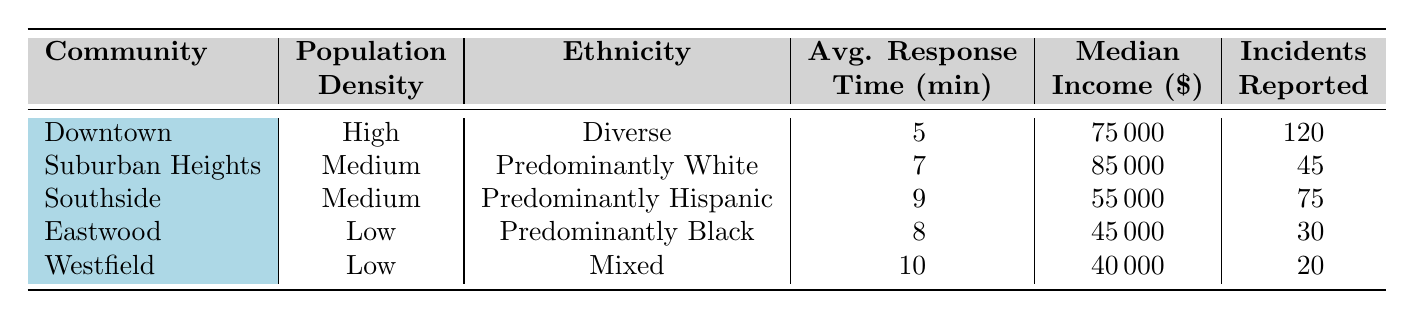What is the average response time for the Downtown community? The average response time for the Downtown community, as indicated in the table, is 5 minutes.
Answer: 5 What is the median income for Southside? The table shows that the median income for Southside is 55,000 dollars.
Answer: 55000 Which community has the highest number of incidents reported? By comparing the "Incidents Reported" column, Downtown has the highest at 120 incidents.
Answer: Downtown Is the average response time for Eastwood less than 9 minutes? The average response time for Eastwood is 8 minutes, which is indeed less than 9 minutes.
Answer: Yes What is the difference in average response time between Westfield and Suburban Heights? Westfield has an average response time of 10 minutes, and Suburban Heights has 7 minutes. The difference is 10 - 7 = 3 minutes.
Answer: 3 Which community has a predominantly Hispanic ethnicity and what is its average response time? Southside has a predominantly Hispanic ethnicity and an average response time of 9 minutes.
Answer: Southside, 9 What is the total number of incidents reported across all communities? Adding up the incidents reported: 120 (Downtown) + 45 (Suburban Heights) + 75 (Southside) + 30 (Eastwood) + 20 (Westfield) equals 290 incidents in total.
Answer: 290 Do any communities have a higher median income than Suburban Heights? Suburban Heights has a median income of 85,000 dollars; no other community in the table exceeds this income, including Southside, Eastwood, and Westfield.
Answer: No What is the average response time for communities with low population density? The communities with low population density are Eastwood and Westfield, with average response times of 8 minutes and 10 minutes, respectively. Therefore, the average is (8 + 10) / 2 = 9 minutes.
Answer: 9 